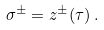<formula> <loc_0><loc_0><loc_500><loc_500>\, \sigma ^ { \pm } = z ^ { \pm } ( \tau ) \, . \,</formula> 